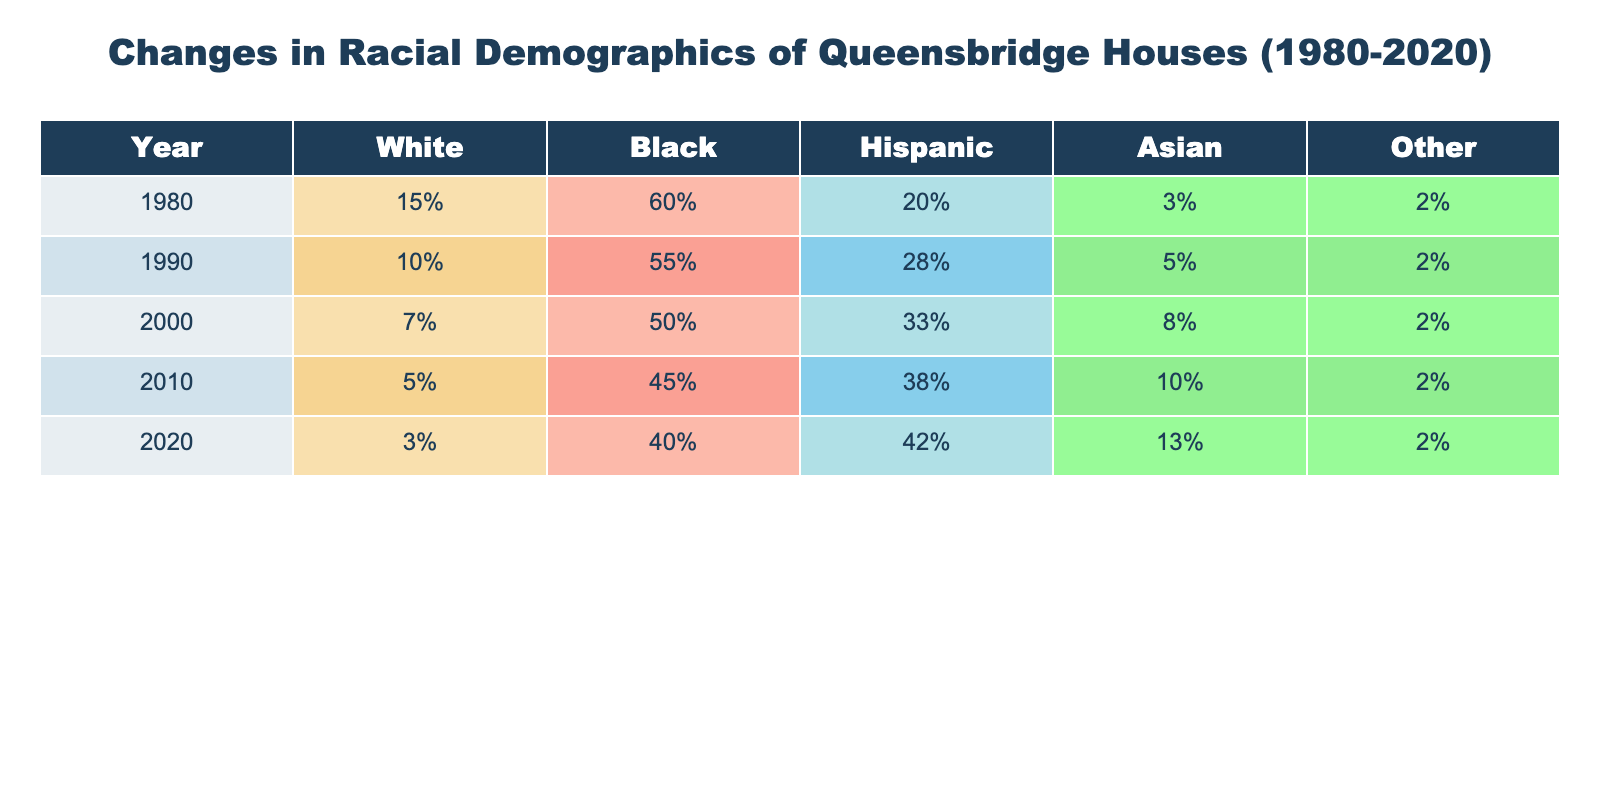What was the percentage of Black residents in Queensbridge Houses in 1990? From the table, the percentage of Black residents in 1990 is directly listed under that year. It shows 55% for Black residents.
Answer: 55% What was the increase in the percentage of Hispanic residents from 1990 to 2020? The percentage of Hispanic residents was 28% in 1990 and 42% in 2020. To find the increase, we subtract the 1990 percentage from the 2020 percentage: 42% - 28% = 14%.
Answer: 14% Is the percentage of White residents consistently decreasing from 1980 to 2020? By examining the table, we can see that the percentage of White residents decreased each decade: from 15% in 1980 to 3% in 2020. Therefore, the statement is true, indicating a consistent decrease.
Answer: Yes What was the total percentage of non-Black residents in 2010? In 2010, the percentages of non-Black residents (White, Hispanic, Asian, and Other) are 5%, 38%, 10%, and 2%, respectively. Adding these values gives: 5% + 38% + 10% + 2% = 55%.
Answer: 55% What demographic change occurred in the Asian population from 2000 to 2020? The table indicates the percentage of Asians was 8% in 2000 and increased to 13% in 2020. This shows an increase of 5%. To calculate: 13% - 8% = 5%.
Answer: Increased by 5% In which decade did the percentage of Black residents drop below 50% for the first time? Looking at the table, the percentage of Black residents fell below 50% in the year 2000, where it was at 50%. This is the first instance it occurred, as in 1990 it was still 55%.
Answer: 2000 What was the combined percentage of White and Asian residents in 2010? In 2010, the White population was 5% and the Asian population was 10%. To find the combined percentage, we add these values: 5% + 10% = 15%.
Answer: 15% By how much did the Other race category change from 1980 to 2020? The Other race category was 2% in 1980 and 2% in 2020. Therefore, it did not change. The calculation shows: 2% - 2% = 0%.
Answer: No change Which demographic had the highest percentage in 1980 and how much did it decrease by 2020? In 1980, the Black demographic had the highest percentage at 60%. By 2020, it decreased to 40%. The decrease is calculated as 60% - 40% = 20%.
Answer: Decreased by 20% 